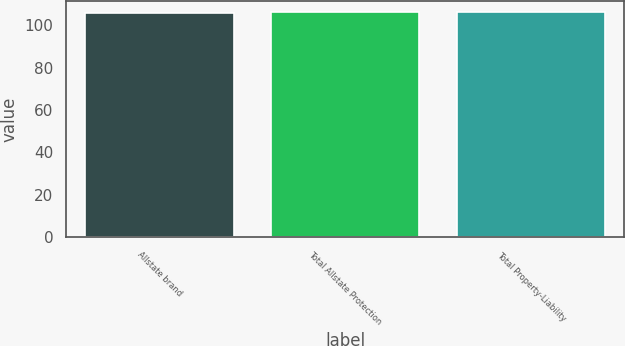Convert chart to OTSL. <chart><loc_0><loc_0><loc_500><loc_500><bar_chart><fcel>Allstate brand<fcel>Total Allstate Protection<fcel>Total Property-Liability<nl><fcel>106<fcel>106.1<fcel>106.2<nl></chart> 